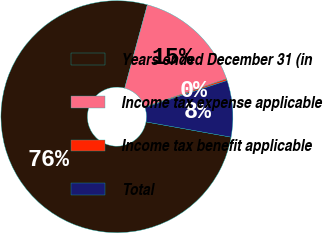Convert chart to OTSL. <chart><loc_0><loc_0><loc_500><loc_500><pie_chart><fcel>Years ended December 31 (in<fcel>Income tax expense applicable<fcel>Income tax benefit applicable<fcel>Total<nl><fcel>76.4%<fcel>15.48%<fcel>0.25%<fcel>7.87%<nl></chart> 